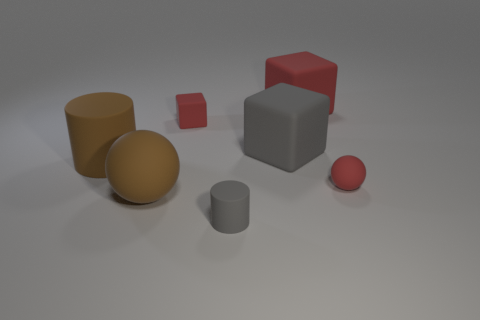What shape is the brown matte object that is the same size as the brown cylinder?
Your answer should be very brief. Sphere. Is there a big brown thing that has the same shape as the small gray matte thing?
Keep it short and to the point. Yes. What material is the red thing in front of the cylinder that is behind the small red rubber sphere made of?
Your response must be concise. Rubber. Are there more small rubber objects on the right side of the small gray thing than small purple metal cylinders?
Keep it short and to the point. Yes. Are there any big red matte objects?
Ensure brevity in your answer.  Yes. The ball on the right side of the large red thing is what color?
Keep it short and to the point. Red. There is a brown object that is the same size as the brown cylinder; what is it made of?
Your answer should be very brief. Rubber. How many other objects are the same material as the brown sphere?
Your response must be concise. 6. There is a big matte object that is to the right of the big matte cylinder and to the left of the tiny rubber block; what is its color?
Keep it short and to the point. Brown. How many objects are either matte cubes on the right side of the tiny red block or big gray cylinders?
Provide a succinct answer. 2. 